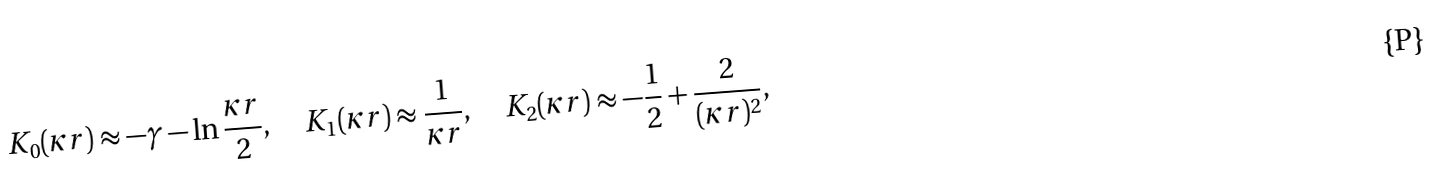<formula> <loc_0><loc_0><loc_500><loc_500>K _ { 0 } ( \kappa r ) \approx - \gamma - \ln \frac { \kappa r } { 2 } , \quad K _ { 1 } ( \kappa r ) \approx \frac { 1 } { \kappa r } , \quad K _ { 2 } ( \kappa r ) \approx - \frac { 1 } { 2 } + \frac { 2 } { ( \kappa r ) ^ { 2 } } ,</formula> 